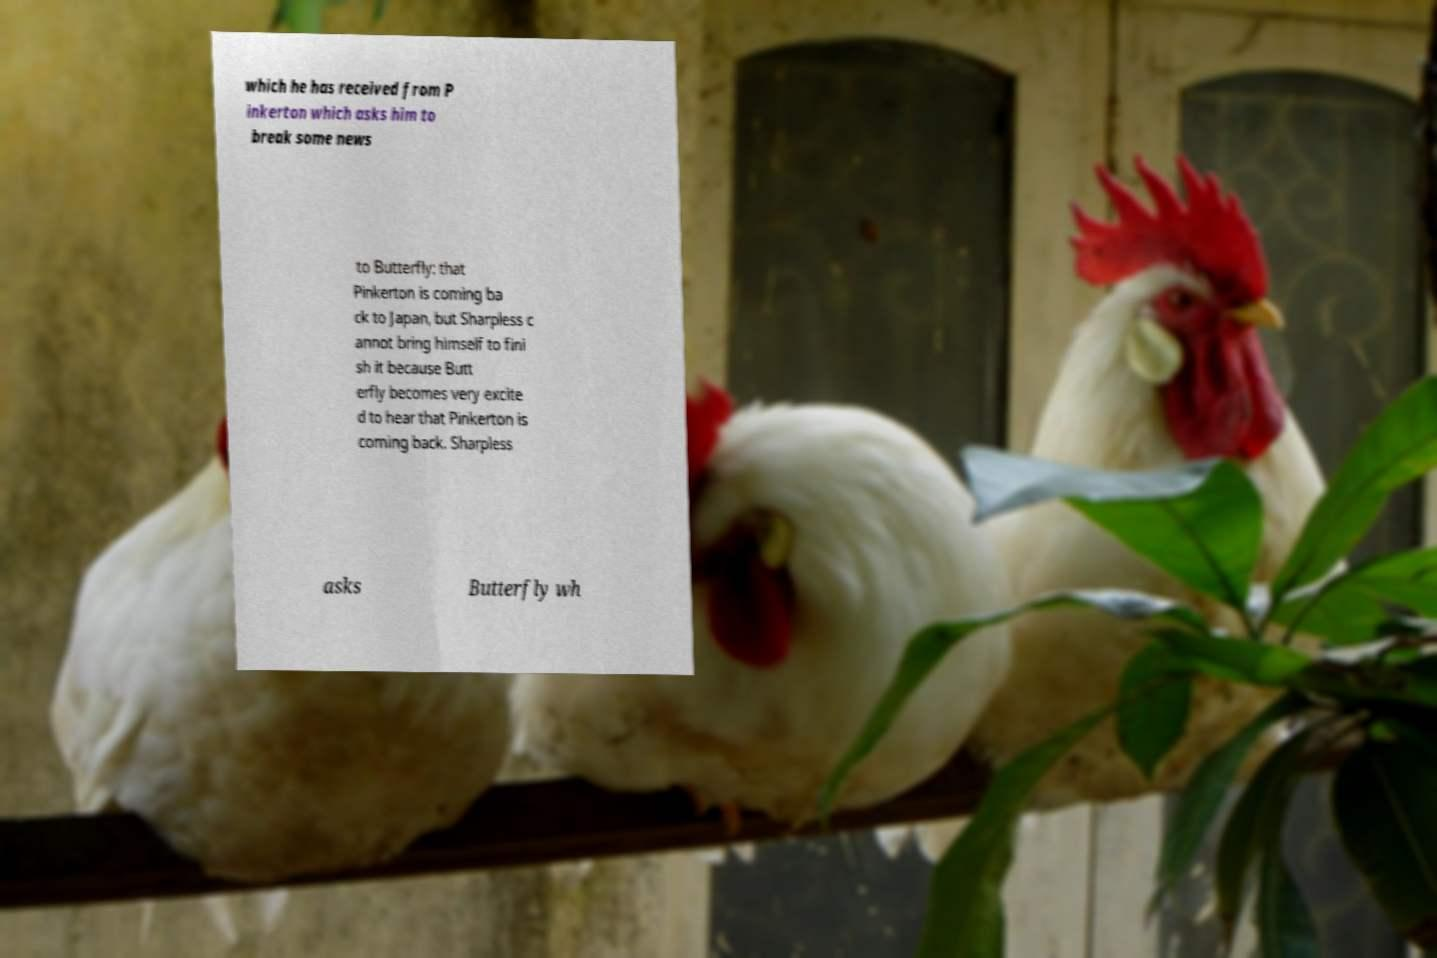There's text embedded in this image that I need extracted. Can you transcribe it verbatim? which he has received from P inkerton which asks him to break some news to Butterfly: that Pinkerton is coming ba ck to Japan, but Sharpless c annot bring himself to fini sh it because Butt erfly becomes very excite d to hear that Pinkerton is coming back. Sharpless asks Butterfly wh 